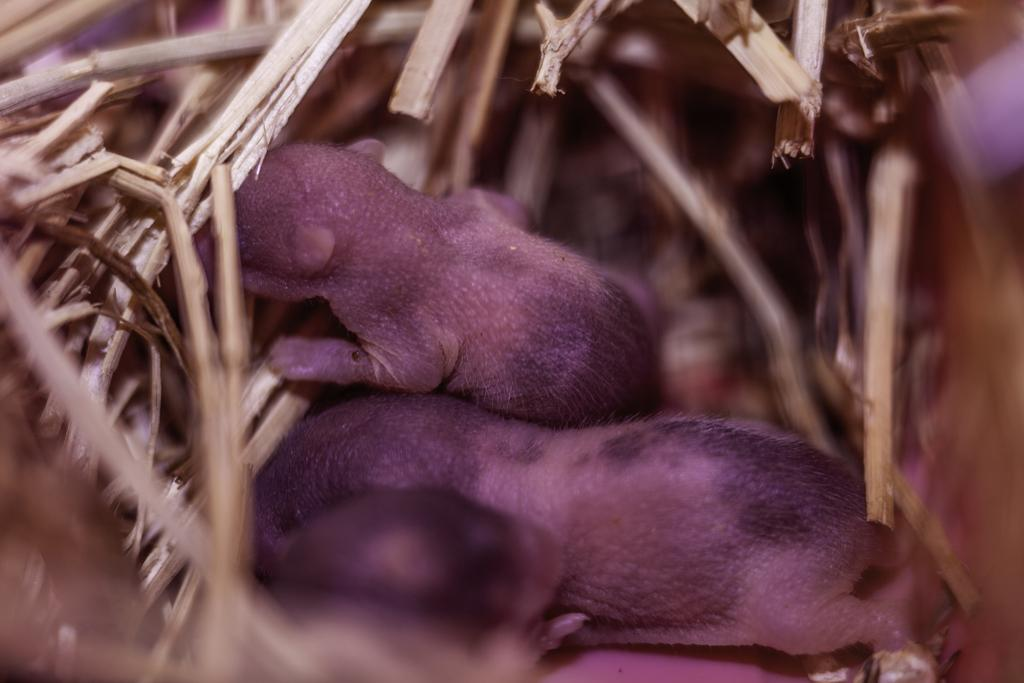What type of animals are in the image? There are kittens of rats in the image. Where are the kittens located? The kittens are in a nest. 